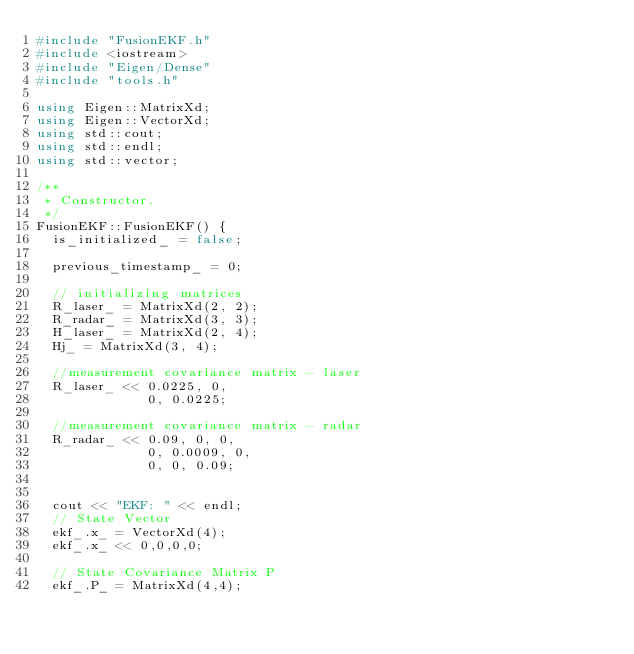Convert code to text. <code><loc_0><loc_0><loc_500><loc_500><_C++_>#include "FusionEKF.h"
#include <iostream>
#include "Eigen/Dense"
#include "tools.h"

using Eigen::MatrixXd;
using Eigen::VectorXd;
using std::cout;
using std::endl;
using std::vector;

/**
 * Constructor.
 */
FusionEKF::FusionEKF() {
  is_initialized_ = false;

  previous_timestamp_ = 0;

  // initializing matrices
  R_laser_ = MatrixXd(2, 2);
  R_radar_ = MatrixXd(3, 3);
  H_laser_ = MatrixXd(2, 4);
  Hj_ = MatrixXd(3, 4);

  //measurement covariance matrix - laser
  R_laser_ << 0.0225, 0,
              0, 0.0225;

  //measurement covariance matrix - radar
  R_radar_ << 0.09, 0, 0,
              0, 0.0009, 0,
              0, 0, 0.09;

  
  cout << "EKF: " << endl;
  // State Vector
  ekf_.x_ = VectorXd(4);
  ekf_.x_ << 0,0,0,0;
  
  // State Covariance Matrix P
  ekf_.P_ = MatrixXd(4,4);</code> 